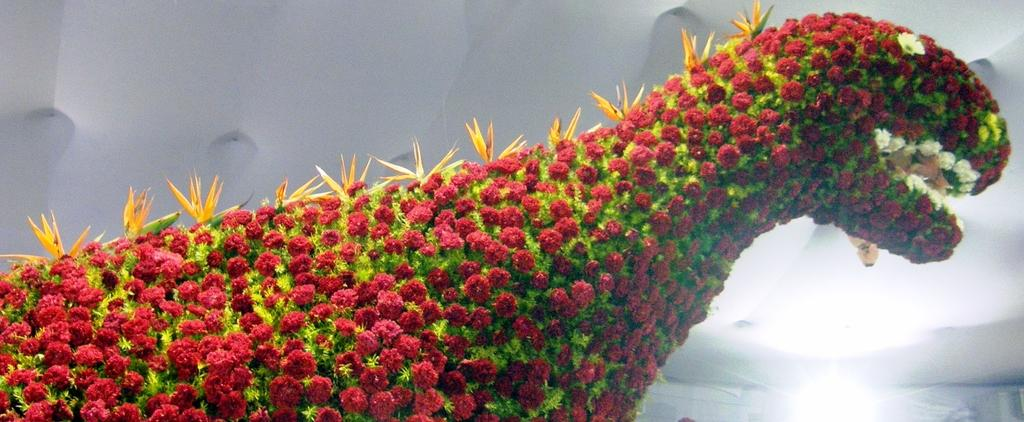What type of animal is present in the image? There is an animal in the image, but its specific type cannot be determined from the provided facts. What can be observed about the animal's appearance? The animal has flower decoration. What color is the background of the image? The background of the image is white. How many copies of the zephyr can be seen in the image? There is no mention of a zephyr in the image, so it cannot be determined how many copies are present. 